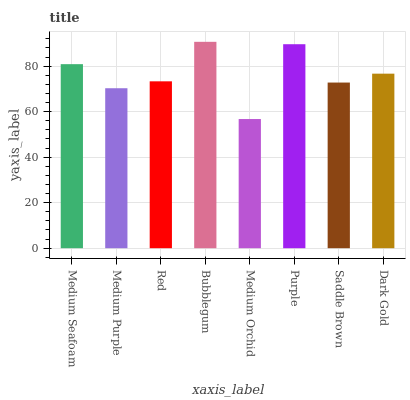Is Medium Orchid the minimum?
Answer yes or no. Yes. Is Bubblegum the maximum?
Answer yes or no. Yes. Is Medium Purple the minimum?
Answer yes or no. No. Is Medium Purple the maximum?
Answer yes or no. No. Is Medium Seafoam greater than Medium Purple?
Answer yes or no. Yes. Is Medium Purple less than Medium Seafoam?
Answer yes or no. Yes. Is Medium Purple greater than Medium Seafoam?
Answer yes or no. No. Is Medium Seafoam less than Medium Purple?
Answer yes or no. No. Is Dark Gold the high median?
Answer yes or no. Yes. Is Red the low median?
Answer yes or no. Yes. Is Medium Seafoam the high median?
Answer yes or no. No. Is Medium Orchid the low median?
Answer yes or no. No. 